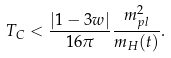Convert formula to latex. <formula><loc_0><loc_0><loc_500><loc_500>T _ { C } < \frac { \left | 1 - 3 w \right | } { 1 6 \pi } \frac { m _ { p l } ^ { 2 } } { m _ { H } ( t ) } .</formula> 